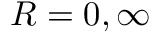<formula> <loc_0><loc_0><loc_500><loc_500>R = 0 , \infty</formula> 